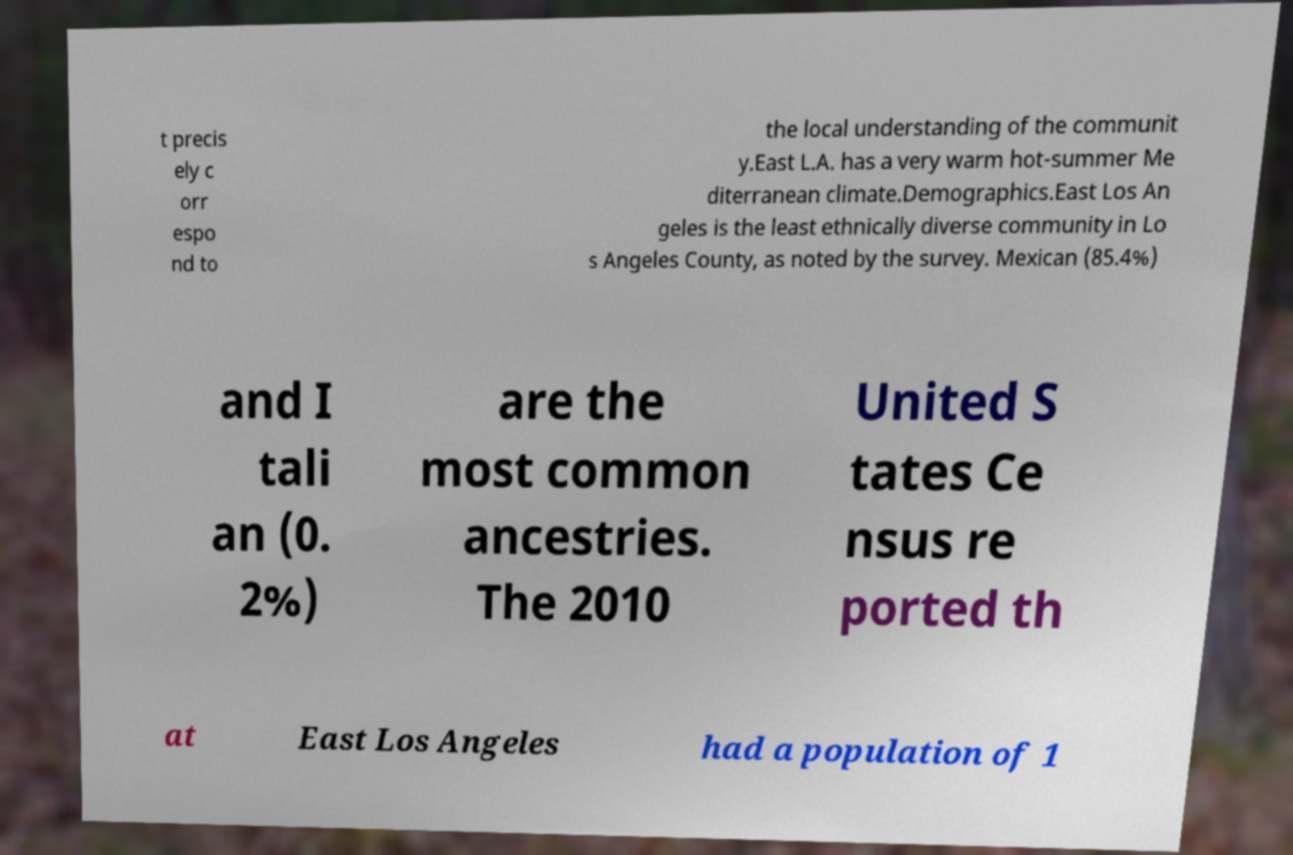I need the written content from this picture converted into text. Can you do that? t precis ely c orr espo nd to the local understanding of the communit y.East L.A. has a very warm hot-summer Me diterranean climate.Demographics.East Los An geles is the least ethnically diverse community in Lo s Angeles County, as noted by the survey. Mexican (85.4%) and I tali an (0. 2%) are the most common ancestries. The 2010 United S tates Ce nsus re ported th at East Los Angeles had a population of 1 